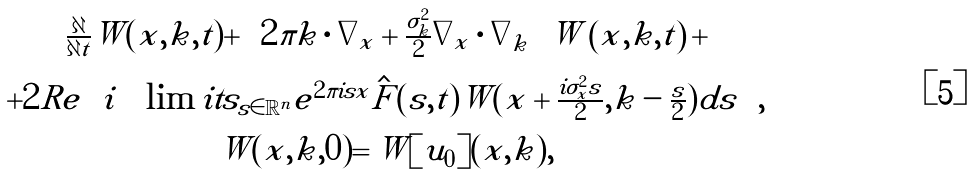Convert formula to latex. <formula><loc_0><loc_0><loc_500><loc_500>\begin{array} { c } \frac { \partial } { \partial t } \tilde { W } ( x , k , t ) + \left ( { 2 \pi k \cdot \nabla _ { x } + \frac { \sigma _ { k } ^ { 2 } } { 2 } \nabla _ { x } \cdot \nabla _ { k } } \right ) \tilde { W } \left ( { x , k , t } \right ) + \\ + 2 R e \left ( { i \int \lim i t s _ { s \in \mathbb { R } ^ { n } } { e ^ { 2 \pi i s x } \hat { F } ( s , t ) \tilde { W } ( x + \frac { i \sigma _ { x } ^ { 2 } s } { 2 } , k - \frac { s } { 2 } ) d s } } \right ) , \\ \tilde { W } ( x , k , 0 ) = \tilde { W } [ u _ { 0 } ] ( x , k ) , \end{array}</formula> 